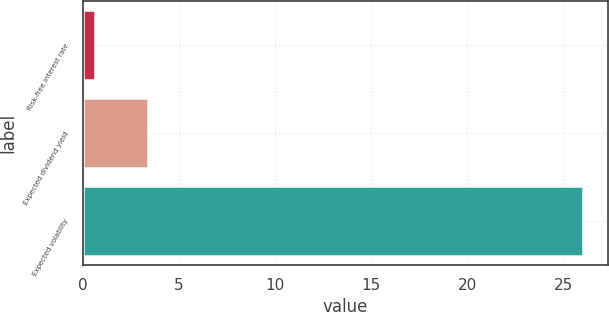<chart> <loc_0><loc_0><loc_500><loc_500><bar_chart><fcel>Risk-free interest rate<fcel>Expected dividend yield<fcel>Expected volatility<nl><fcel>0.62<fcel>3.39<fcel>26<nl></chart> 